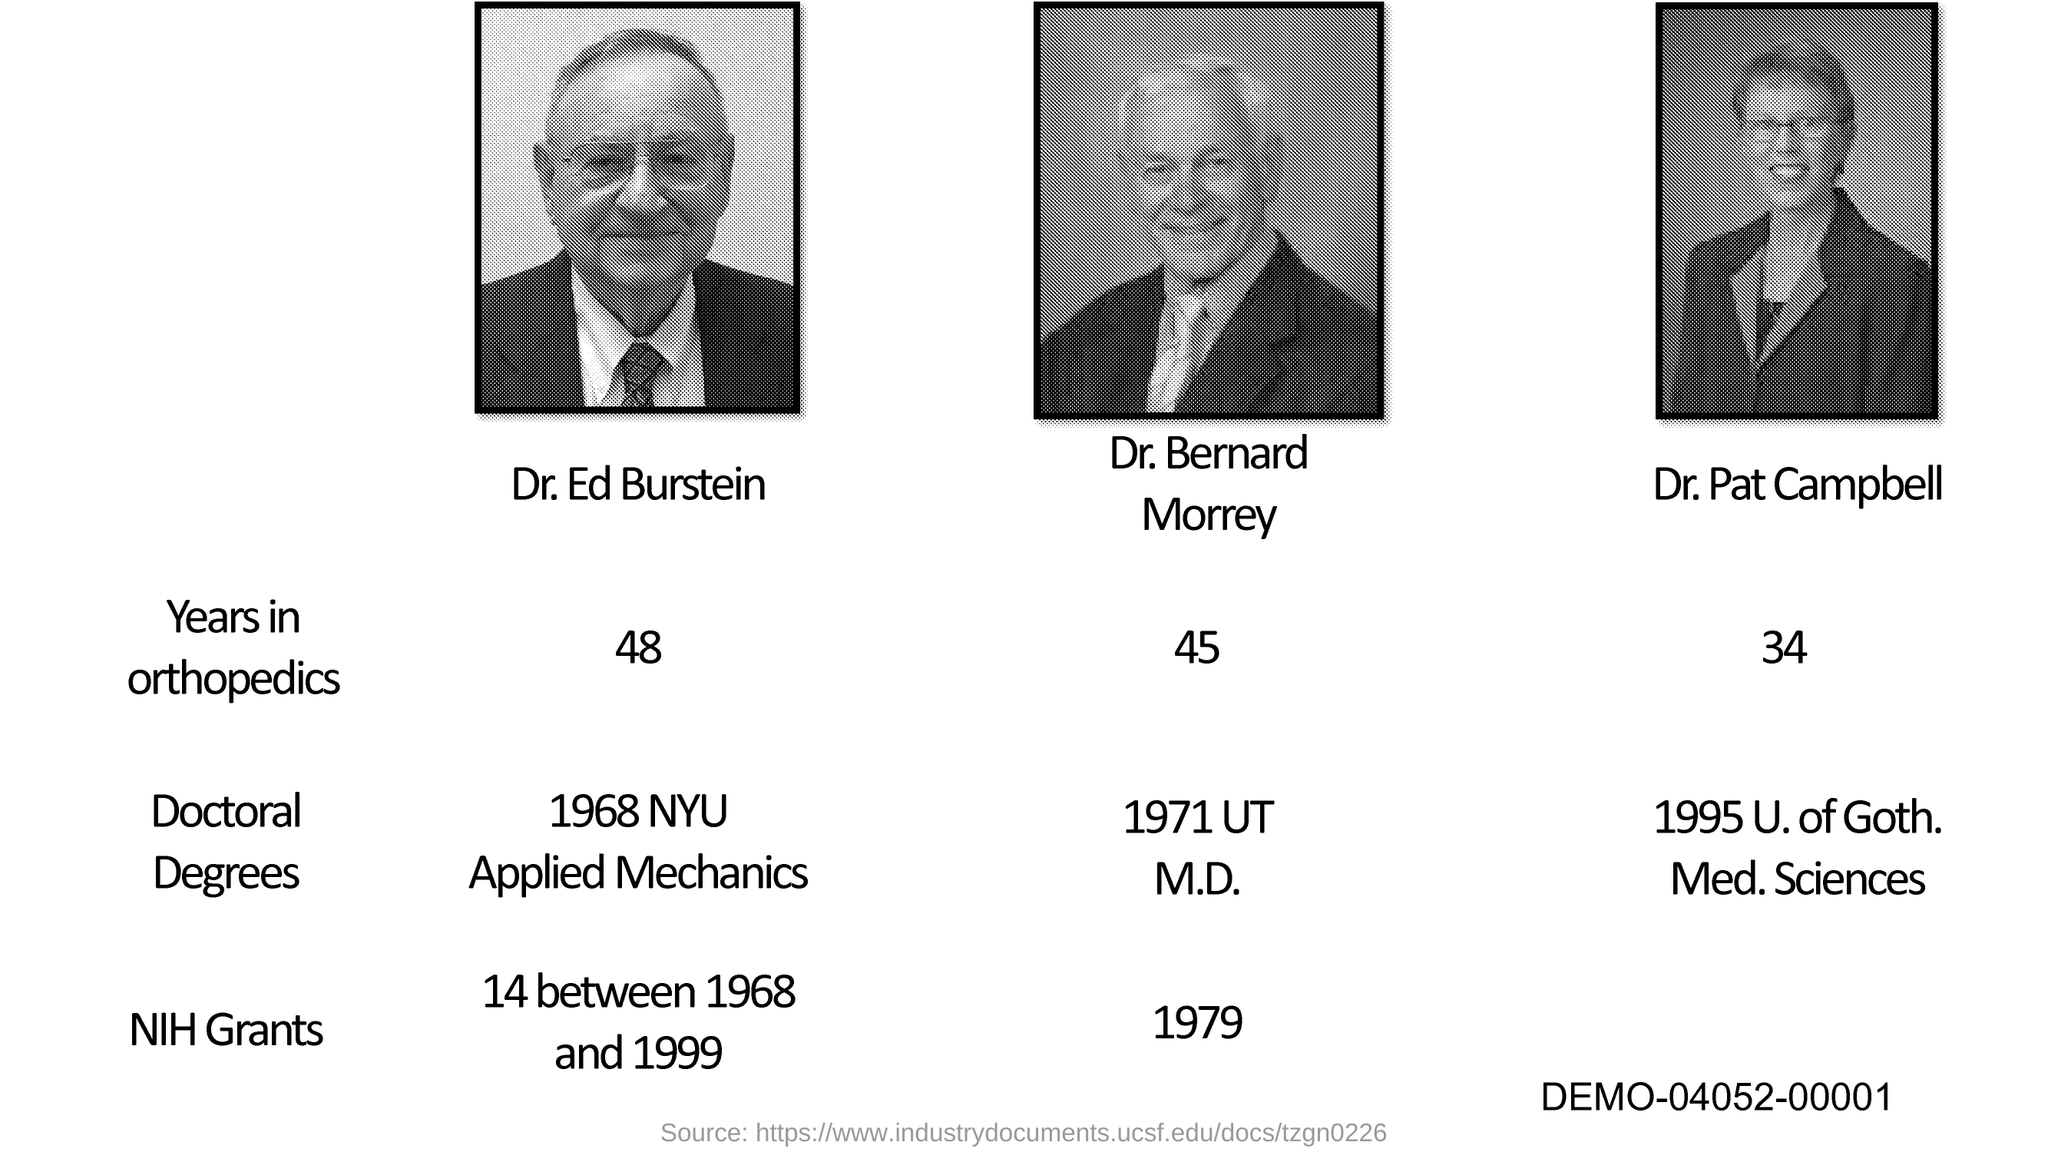What is the years of experience of Dr. Ed Burstein in orthopedics?
Offer a very short reply. 48. What is the years of experience of Dr. Bernard Morrey in orthopedics?
Your response must be concise. 45. In which university, Dr. Pat Campbell did his doctoral degree?
Your answer should be very brief. 1995 U. of Goth. Med. Sciences. What is the years of experience of Dr. Pat Campbell in orthopedics?
Offer a very short reply. 34. In Which year, Dr. Bernard Morrey received NIH Grants?
Provide a succinct answer. 1979. 